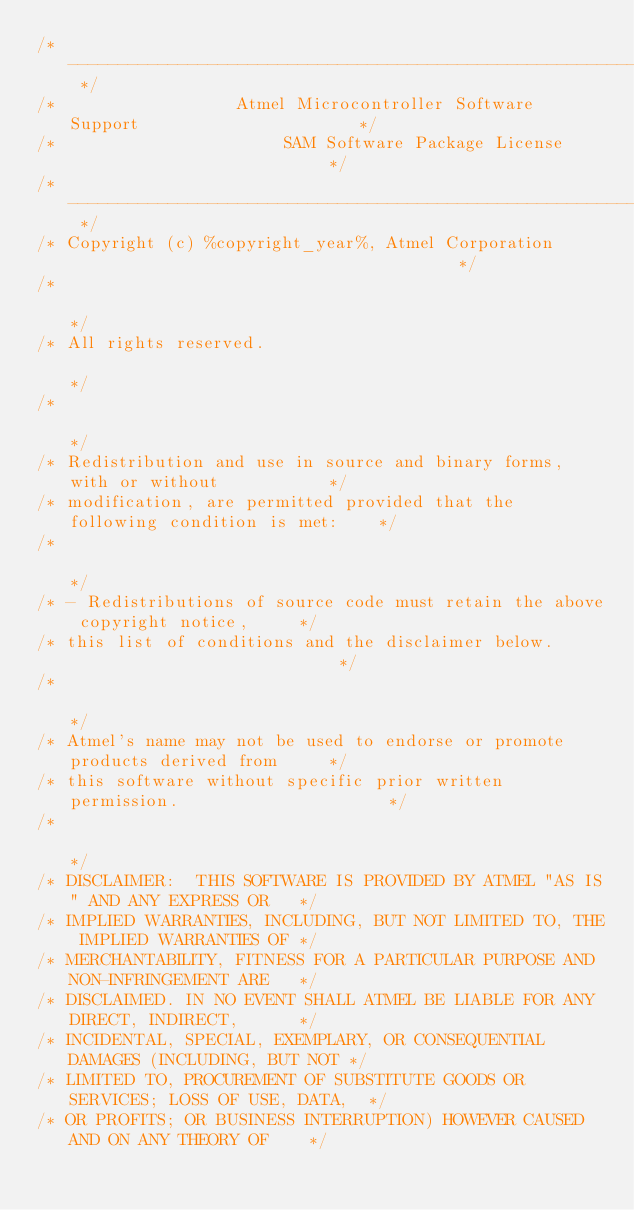Convert code to text. <code><loc_0><loc_0><loc_500><loc_500><_C_>/* ---------------------------------------------------------------------------- */
/*                  Atmel Microcontroller Software Support                      */
/*                       SAM Software Package License                           */
/* ---------------------------------------------------------------------------- */
/* Copyright (c) %copyright_year%, Atmel Corporation                                        */
/*                                                                              */
/* All rights reserved.                                                         */
/*                                                                              */
/* Redistribution and use in source and binary forms, with or without           */
/* modification, are permitted provided that the following condition is met:    */
/*                                                                              */
/* - Redistributions of source code must retain the above copyright notice,     */
/* this list of conditions and the disclaimer below.                            */
/*                                                                              */
/* Atmel's name may not be used to endorse or promote products derived from     */
/* this software without specific prior written permission.                     */
/*                                                                              */
/* DISCLAIMER:  THIS SOFTWARE IS PROVIDED BY ATMEL "AS IS" AND ANY EXPRESS OR   */
/* IMPLIED WARRANTIES, INCLUDING, BUT NOT LIMITED TO, THE IMPLIED WARRANTIES OF */
/* MERCHANTABILITY, FITNESS FOR A PARTICULAR PURPOSE AND NON-INFRINGEMENT ARE   */
/* DISCLAIMED. IN NO EVENT SHALL ATMEL BE LIABLE FOR ANY DIRECT, INDIRECT,      */
/* INCIDENTAL, SPECIAL, EXEMPLARY, OR CONSEQUENTIAL DAMAGES (INCLUDING, BUT NOT */
/* LIMITED TO, PROCUREMENT OF SUBSTITUTE GOODS OR SERVICES; LOSS OF USE, DATA,  */
/* OR PROFITS; OR BUSINESS INTERRUPTION) HOWEVER CAUSED AND ON ANY THEORY OF    */</code> 